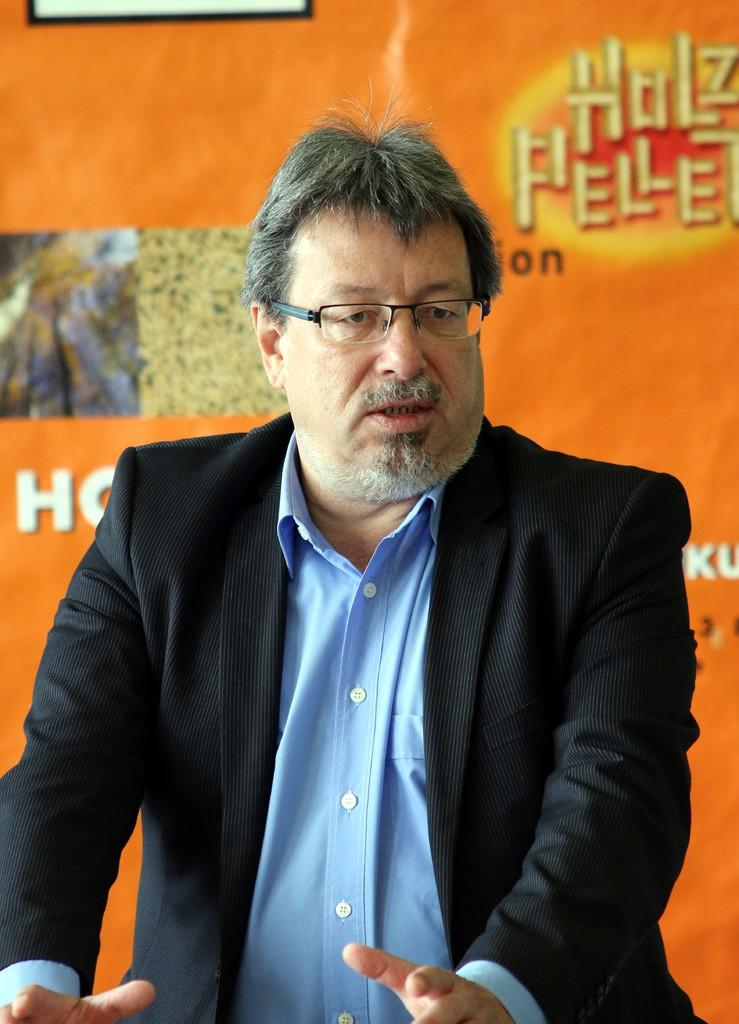What is the main subject of the image? There is a person in the image. What is the person wearing? The person is wearing a black suit. What is the person's posture in the image? The person is standing. What can be seen in the background of the image? There is a banner in the image. What is depicted on the banner? The banner has images and other objects on it. What team is the person supporting in the image? There is no indication of a team or any sports-related context in the image. What day of the week is depicted in the image? The image does not show any specific day of the week. 